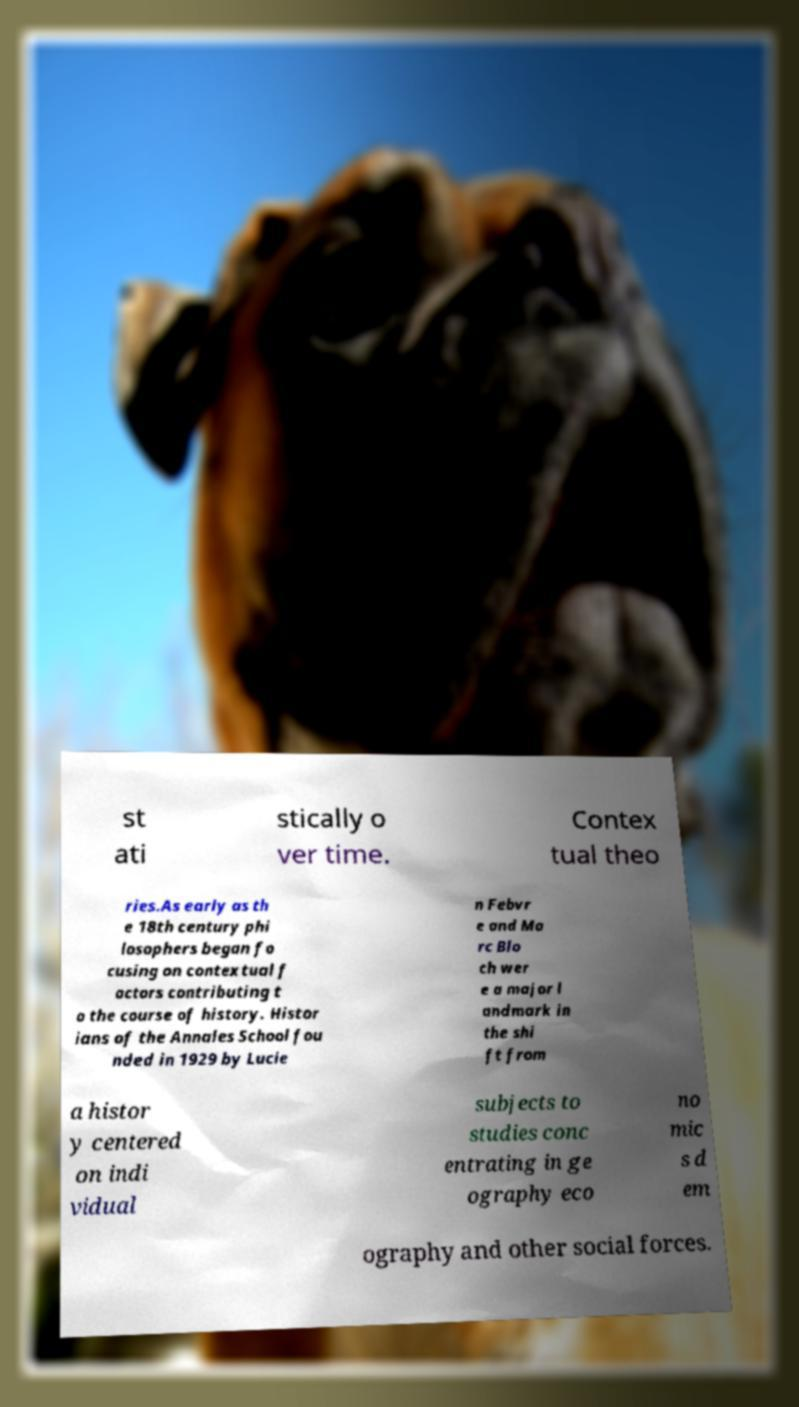For documentation purposes, I need the text within this image transcribed. Could you provide that? st ati stically o ver time. Contex tual theo ries.As early as th e 18th century phi losophers began fo cusing on contextual f actors contributing t o the course of history. Histor ians of the Annales School fou nded in 1929 by Lucie n Febvr e and Ma rc Blo ch wer e a major l andmark in the shi ft from a histor y centered on indi vidual subjects to studies conc entrating in ge ography eco no mic s d em ography and other social forces. 